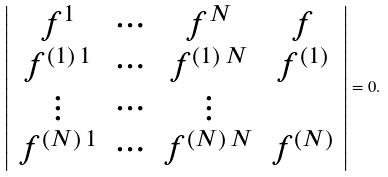<formula> <loc_0><loc_0><loc_500><loc_500>\left | \begin{array} { c c c c } f ^ { 1 } & \cdots & f ^ { N } & f \\ f ^ { ( 1 ) \, 1 } & \cdots & f ^ { ( 1 ) \, N } & f ^ { ( 1 ) } \\ \vdots & \cdots & \vdots \\ f ^ { ( N ) \, 1 } & \cdots & f ^ { ( N ) \, N } & f ^ { ( N ) } \\ \end{array} \right | = 0 .</formula> 